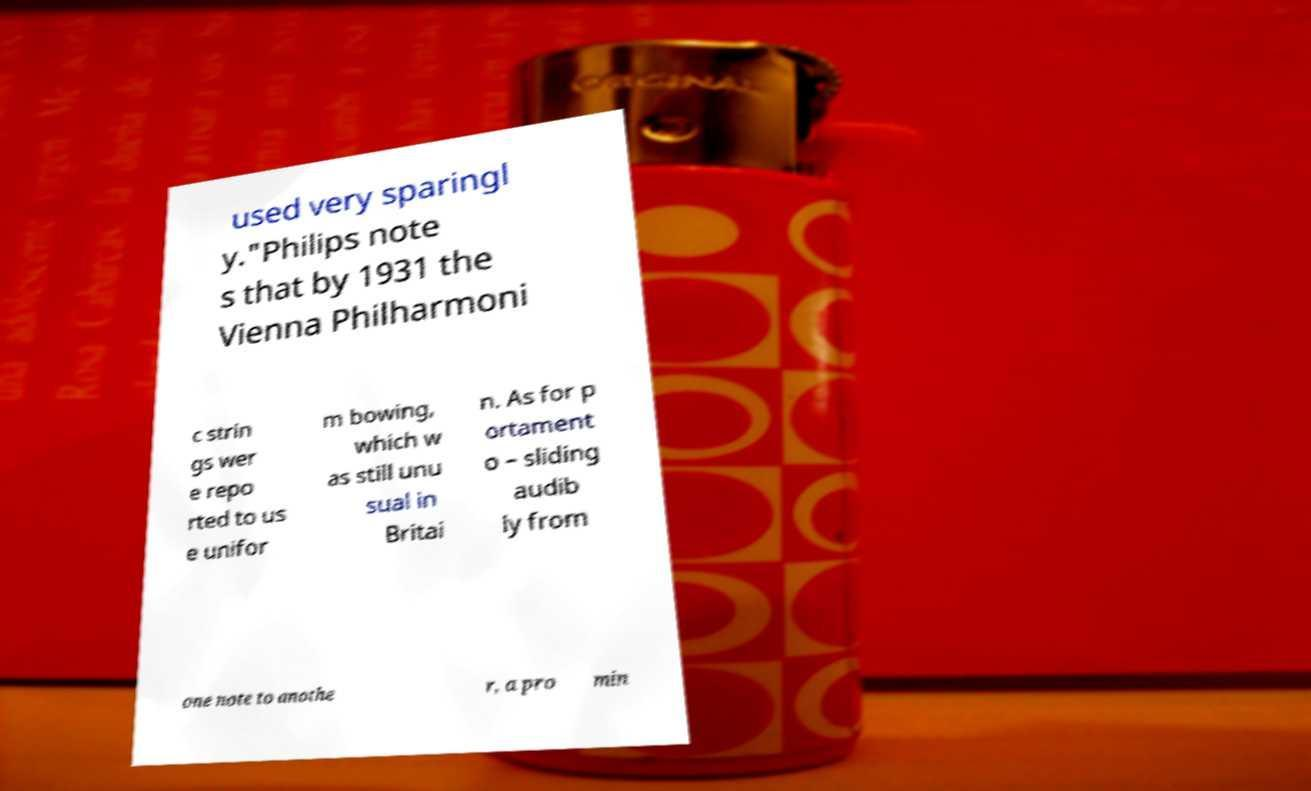I need the written content from this picture converted into text. Can you do that? used very sparingl y."Philips note s that by 1931 the Vienna Philharmoni c strin gs wer e repo rted to us e unifor m bowing, which w as still unu sual in Britai n. As for p ortament o – sliding audib ly from one note to anothe r, a pro min 